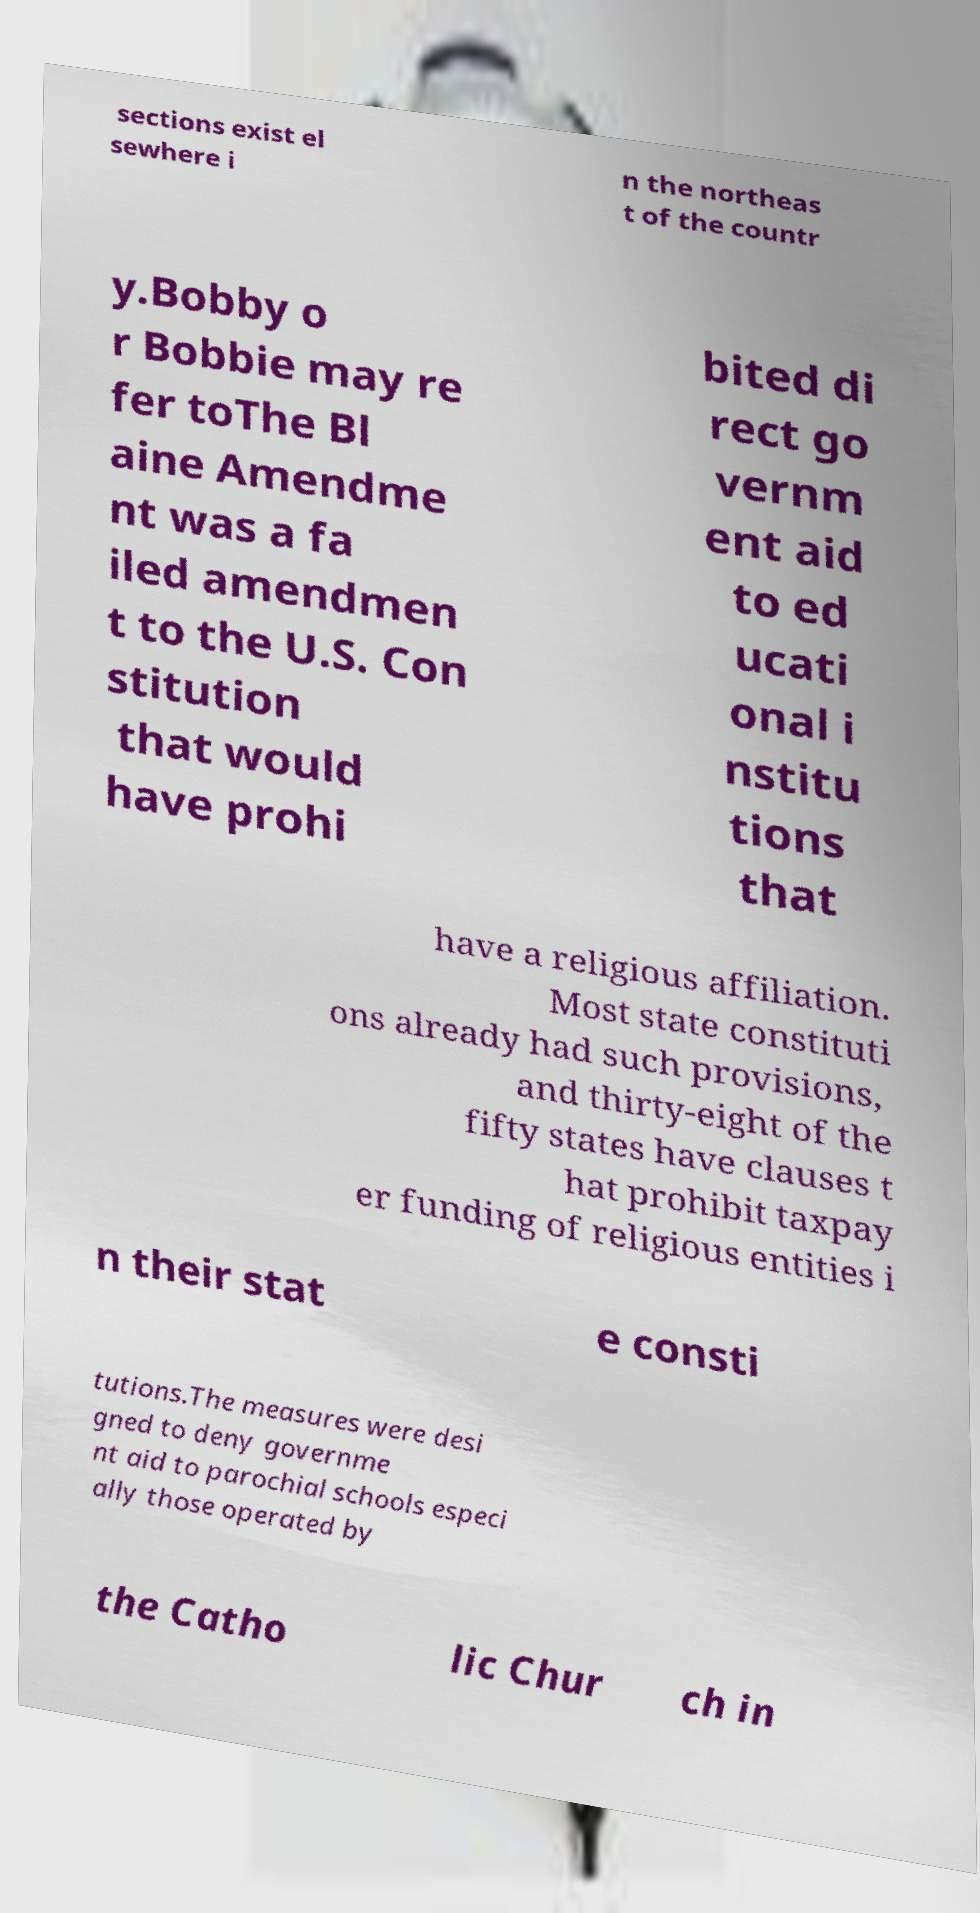I need the written content from this picture converted into text. Can you do that? sections exist el sewhere i n the northeas t of the countr y.Bobby o r Bobbie may re fer toThe Bl aine Amendme nt was a fa iled amendmen t to the U.S. Con stitution that would have prohi bited di rect go vernm ent aid to ed ucati onal i nstitu tions that have a religious affiliation. Most state constituti ons already had such provisions, and thirty-eight of the fifty states have clauses t hat prohibit taxpay er funding of religious entities i n their stat e consti tutions.The measures were desi gned to deny governme nt aid to parochial schools especi ally those operated by the Catho lic Chur ch in 